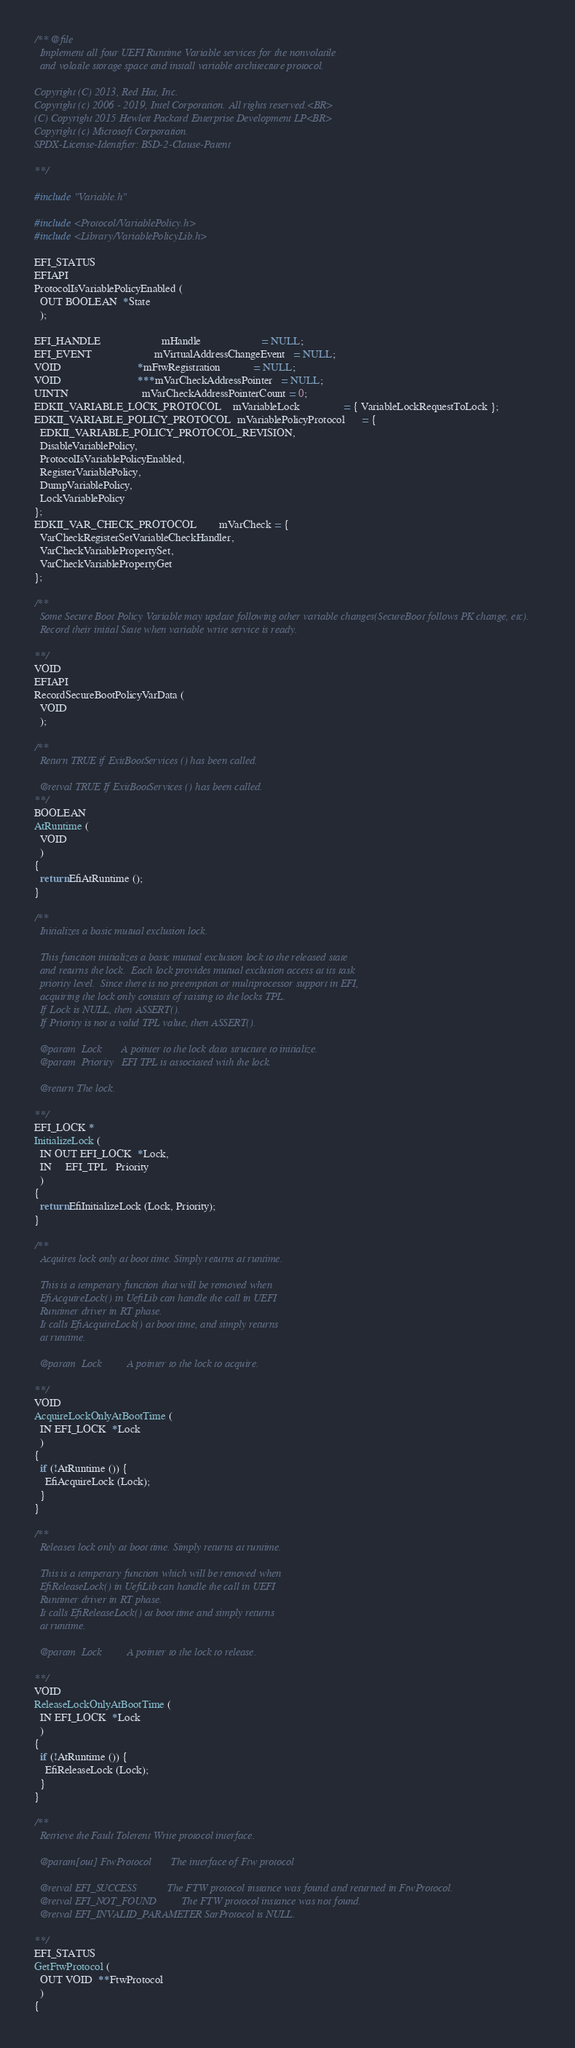Convert code to text. <code><loc_0><loc_0><loc_500><loc_500><_C_>/** @file
  Implement all four UEFI Runtime Variable services for the nonvolatile
  and volatile storage space and install variable architecture protocol.

Copyright (C) 2013, Red Hat, Inc.
Copyright (c) 2006 - 2019, Intel Corporation. All rights reserved.<BR>
(C) Copyright 2015 Hewlett Packard Enterprise Development LP<BR>
Copyright (c) Microsoft Corporation.
SPDX-License-Identifier: BSD-2-Clause-Patent

**/

#include "Variable.h"

#include <Protocol/VariablePolicy.h>
#include <Library/VariablePolicyLib.h>

EFI_STATUS
EFIAPI
ProtocolIsVariablePolicyEnabled (
  OUT BOOLEAN  *State
  );

EFI_HANDLE                      mHandle                      = NULL;
EFI_EVENT                       mVirtualAddressChangeEvent   = NULL;
VOID                            *mFtwRegistration            = NULL;
VOID                            ***mVarCheckAddressPointer   = NULL;
UINTN                           mVarCheckAddressPointerCount = 0;
EDKII_VARIABLE_LOCK_PROTOCOL    mVariableLock                = { VariableLockRequestToLock };
EDKII_VARIABLE_POLICY_PROTOCOL  mVariablePolicyProtocol      = {
  EDKII_VARIABLE_POLICY_PROTOCOL_REVISION,
  DisableVariablePolicy,
  ProtocolIsVariablePolicyEnabled,
  RegisterVariablePolicy,
  DumpVariablePolicy,
  LockVariablePolicy
};
EDKII_VAR_CHECK_PROTOCOL        mVarCheck = {
  VarCheckRegisterSetVariableCheckHandler,
  VarCheckVariablePropertySet,
  VarCheckVariablePropertyGet
};

/**
  Some Secure Boot Policy Variable may update following other variable changes(SecureBoot follows PK change, etc).
  Record their initial State when variable write service is ready.

**/
VOID
EFIAPI
RecordSecureBootPolicyVarData (
  VOID
  );

/**
  Return TRUE if ExitBootServices () has been called.

  @retval TRUE If ExitBootServices () has been called.
**/
BOOLEAN
AtRuntime (
  VOID
  )
{
  return EfiAtRuntime ();
}

/**
  Initializes a basic mutual exclusion lock.

  This function initializes a basic mutual exclusion lock to the released state
  and returns the lock.  Each lock provides mutual exclusion access at its task
  priority level.  Since there is no preemption or multiprocessor support in EFI,
  acquiring the lock only consists of raising to the locks TPL.
  If Lock is NULL, then ASSERT().
  If Priority is not a valid TPL value, then ASSERT().

  @param  Lock       A pointer to the lock data structure to initialize.
  @param  Priority   EFI TPL is associated with the lock.

  @return The lock.

**/
EFI_LOCK *
InitializeLock (
  IN OUT EFI_LOCK  *Lock,
  IN     EFI_TPL   Priority
  )
{
  return EfiInitializeLock (Lock, Priority);
}

/**
  Acquires lock only at boot time. Simply returns at runtime.

  This is a temperary function that will be removed when
  EfiAcquireLock() in UefiLib can handle the call in UEFI
  Runtimer driver in RT phase.
  It calls EfiAcquireLock() at boot time, and simply returns
  at runtime.

  @param  Lock         A pointer to the lock to acquire.

**/
VOID
AcquireLockOnlyAtBootTime (
  IN EFI_LOCK  *Lock
  )
{
  if (!AtRuntime ()) {
    EfiAcquireLock (Lock);
  }
}

/**
  Releases lock only at boot time. Simply returns at runtime.

  This is a temperary function which will be removed when
  EfiReleaseLock() in UefiLib can handle the call in UEFI
  Runtimer driver in RT phase.
  It calls EfiReleaseLock() at boot time and simply returns
  at runtime.

  @param  Lock         A pointer to the lock to release.

**/
VOID
ReleaseLockOnlyAtBootTime (
  IN EFI_LOCK  *Lock
  )
{
  if (!AtRuntime ()) {
    EfiReleaseLock (Lock);
  }
}

/**
  Retrieve the Fault Tolerent Write protocol interface.

  @param[out] FtwProtocol       The interface of Ftw protocol

  @retval EFI_SUCCESS           The FTW protocol instance was found and returned in FtwProtocol.
  @retval EFI_NOT_FOUND         The FTW protocol instance was not found.
  @retval EFI_INVALID_PARAMETER SarProtocol is NULL.

**/
EFI_STATUS
GetFtwProtocol (
  OUT VOID  **FtwProtocol
  )
{</code> 